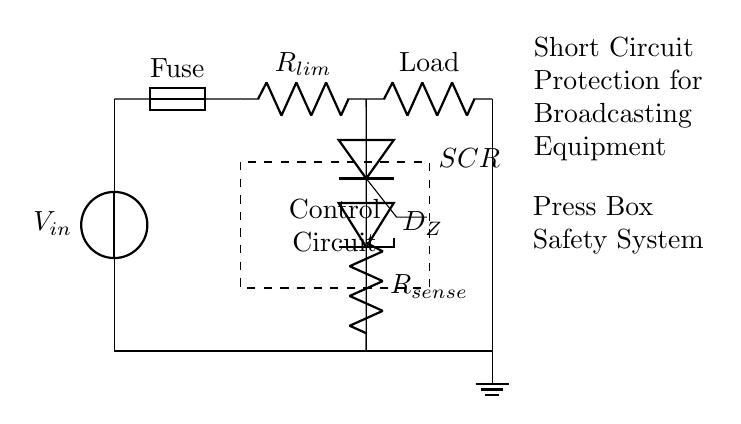What component is used for current-limiting? The current-limiting function is achieved by the resistor labeled R_lim, which restricts current flow to prevent damage to the equipment.
Answer: R_lim What type of protection does the SCR provide? The SCR functions as a crowbar circuit that protects the broadcasting equipment by shorting the supply voltage to ground in case of a fault or excessive current, effectively safeguarding the load.
Answer: Crowbar What is the function of the fuse in this circuit? The fuse acts as a safety device that disconnects the circuit in case of an overload or short circuit, thus preventing potential damage to the equipment and ensuring safe operation.
Answer: Disconnect What connects the load to the ground? The load is connected to the ground through a direct path represented by the wire leading downwards from the load terminal to the ground symbol at the bottom of the diagram.
Answer: Wire connection How does the control circuit interact with the SCR? The control circuit monitors the current through R_sense and triggers the SCR to short the load to ground when it detects a fault, thus providing timely protection for the equipment.
Answer: Monitors What is the purpose of the Zener diode in this circuit? The Zener diode, indicated as D_Z, regulates the voltage across the load to a specified level, ensuring that the broadcasting equipment operates within safe voltage limits.
Answer: Voltage regulation What is the role of resistor R_sense in this configuration? Resistor R_sense detects the current flowing through the circuit; if the current exceeds a predefined threshold, it signals the control circuit to activate the SCR for protection.
Answer: Current sensing 